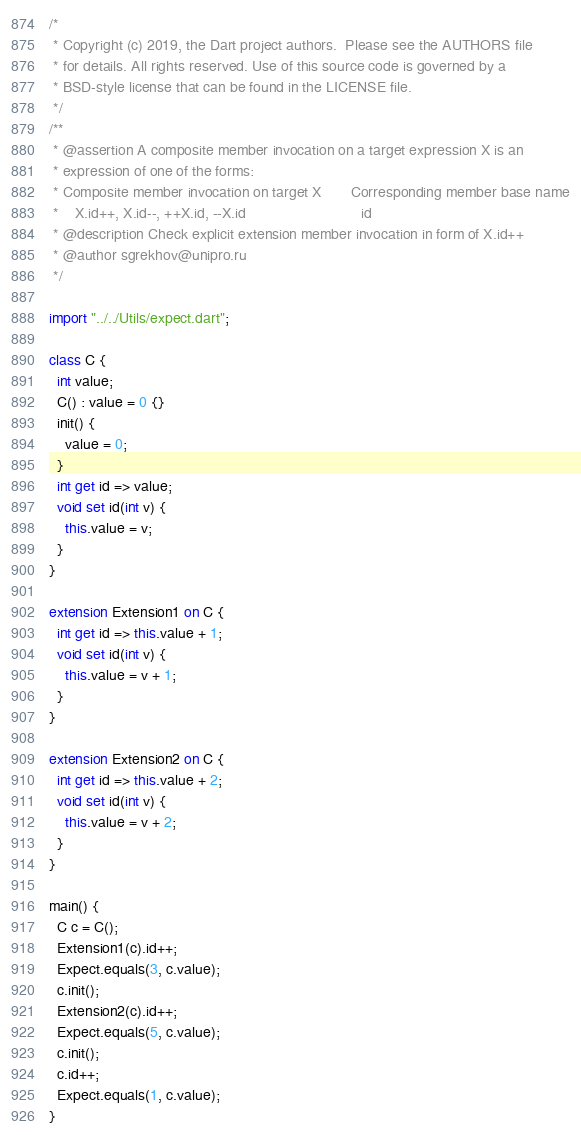Convert code to text. <code><loc_0><loc_0><loc_500><loc_500><_Dart_>/*
 * Copyright (c) 2019, the Dart project authors.  Please see the AUTHORS file
 * for details. All rights reserved. Use of this source code is governed by a
 * BSD-style license that can be found in the LICENSE file.
 */
/**
 * @assertion A composite member invocation on a target expression X is an
 * expression of one of the forms:
 * Composite member invocation on target X	     Corresponding member base name
 *    X.id++, X.id--, ++X.id, --X.id	                        id
 * @description Check explicit extension member invocation in form of X.id++
 * @author sgrekhov@unipro.ru
 */

import "../../Utils/expect.dart";

class C {
  int value;
  C() : value = 0 {}
  init() {
    value = 0;
  }
  int get id => value;
  void set id(int v) {
    this.value = v;
  }
}

extension Extension1 on C {
  int get id => this.value + 1;
  void set id(int v) {
    this.value = v + 1;
  }
}

extension Extension2 on C {
  int get id => this.value + 2;
  void set id(int v) {
    this.value = v + 2;
  }
}

main() {
  C c = C();
  Extension1(c).id++;
  Expect.equals(3, c.value);
  c.init();
  Extension2(c).id++;
  Expect.equals(5, c.value);
  c.init();
  c.id++;
  Expect.equals(1, c.value);
}
</code> 